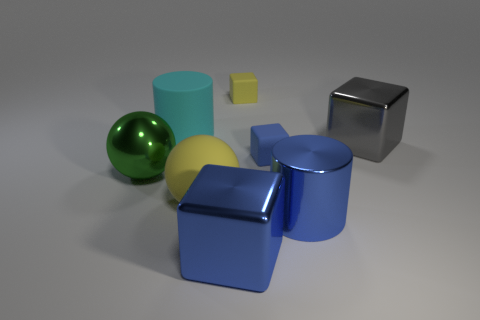Are there more metallic cubes in front of the big yellow rubber ball than yellow objects?
Your response must be concise. No. What is the shape of the green shiny thing?
Offer a very short reply. Sphere. There is a block that is in front of the big green ball; is it the same color as the big metal thing behind the big green metal thing?
Give a very brief answer. No. Do the green object and the tiny yellow object have the same shape?
Offer a terse response. No. Is there any other thing that has the same shape as the cyan rubber object?
Your response must be concise. Yes. Do the green thing left of the blue metal cylinder and the yellow cube have the same material?
Keep it short and to the point. No. The metallic thing that is to the left of the tiny yellow object and in front of the metal sphere has what shape?
Offer a terse response. Cube. Is there a yellow rubber block behind the big sphere that is in front of the big green shiny ball?
Give a very brief answer. Yes. How many other things are the same material as the yellow ball?
Make the answer very short. 3. There is a large rubber thing on the right side of the cyan rubber cylinder; is its shape the same as the yellow matte object that is behind the large gray object?
Provide a succinct answer. No. 